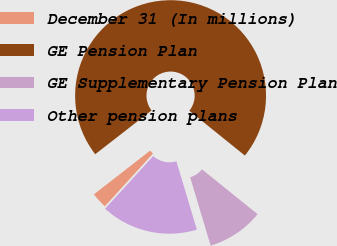Convert chart to OTSL. <chart><loc_0><loc_0><loc_500><loc_500><pie_chart><fcel>December 31 (In millions)<fcel>GE Pension Plan<fcel>GE Supplementary Pension Plan<fcel>Other pension plans<nl><fcel>2.7%<fcel>71.31%<fcel>9.56%<fcel>16.42%<nl></chart> 